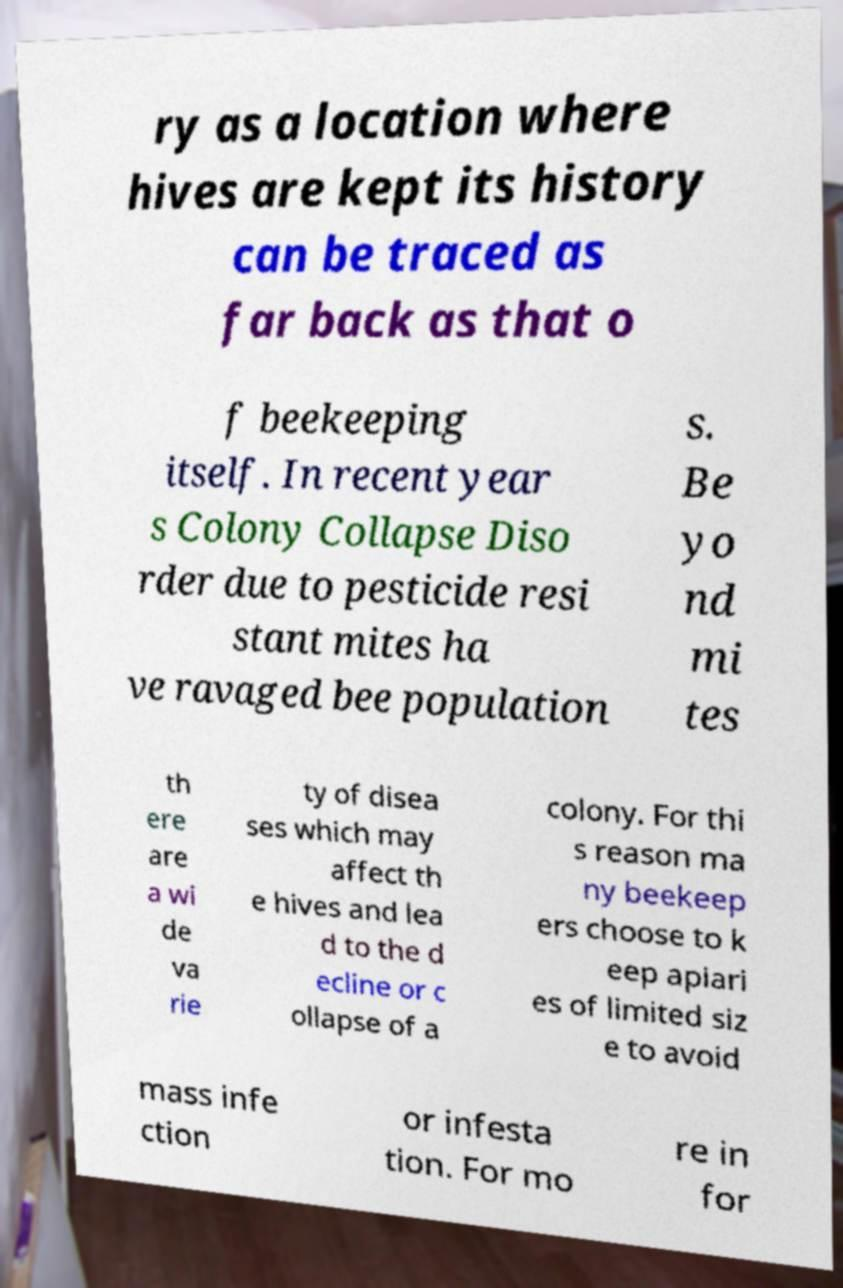Could you extract and type out the text from this image? ry as a location where hives are kept its history can be traced as far back as that o f beekeeping itself. In recent year s Colony Collapse Diso rder due to pesticide resi stant mites ha ve ravaged bee population s. Be yo nd mi tes th ere are a wi de va rie ty of disea ses which may affect th e hives and lea d to the d ecline or c ollapse of a colony. For thi s reason ma ny beekeep ers choose to k eep apiari es of limited siz e to avoid mass infe ction or infesta tion. For mo re in for 